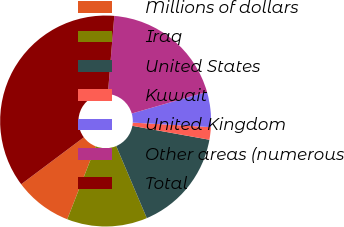Convert chart to OTSL. <chart><loc_0><loc_0><loc_500><loc_500><pie_chart><fcel>Millions of dollars<fcel>Iraq<fcel>United States<fcel>Kuwait<fcel>United Kingdom<fcel>Other areas (numerous<fcel>Total<nl><fcel>8.85%<fcel>12.31%<fcel>15.77%<fcel>1.92%<fcel>5.38%<fcel>19.23%<fcel>36.54%<nl></chart> 